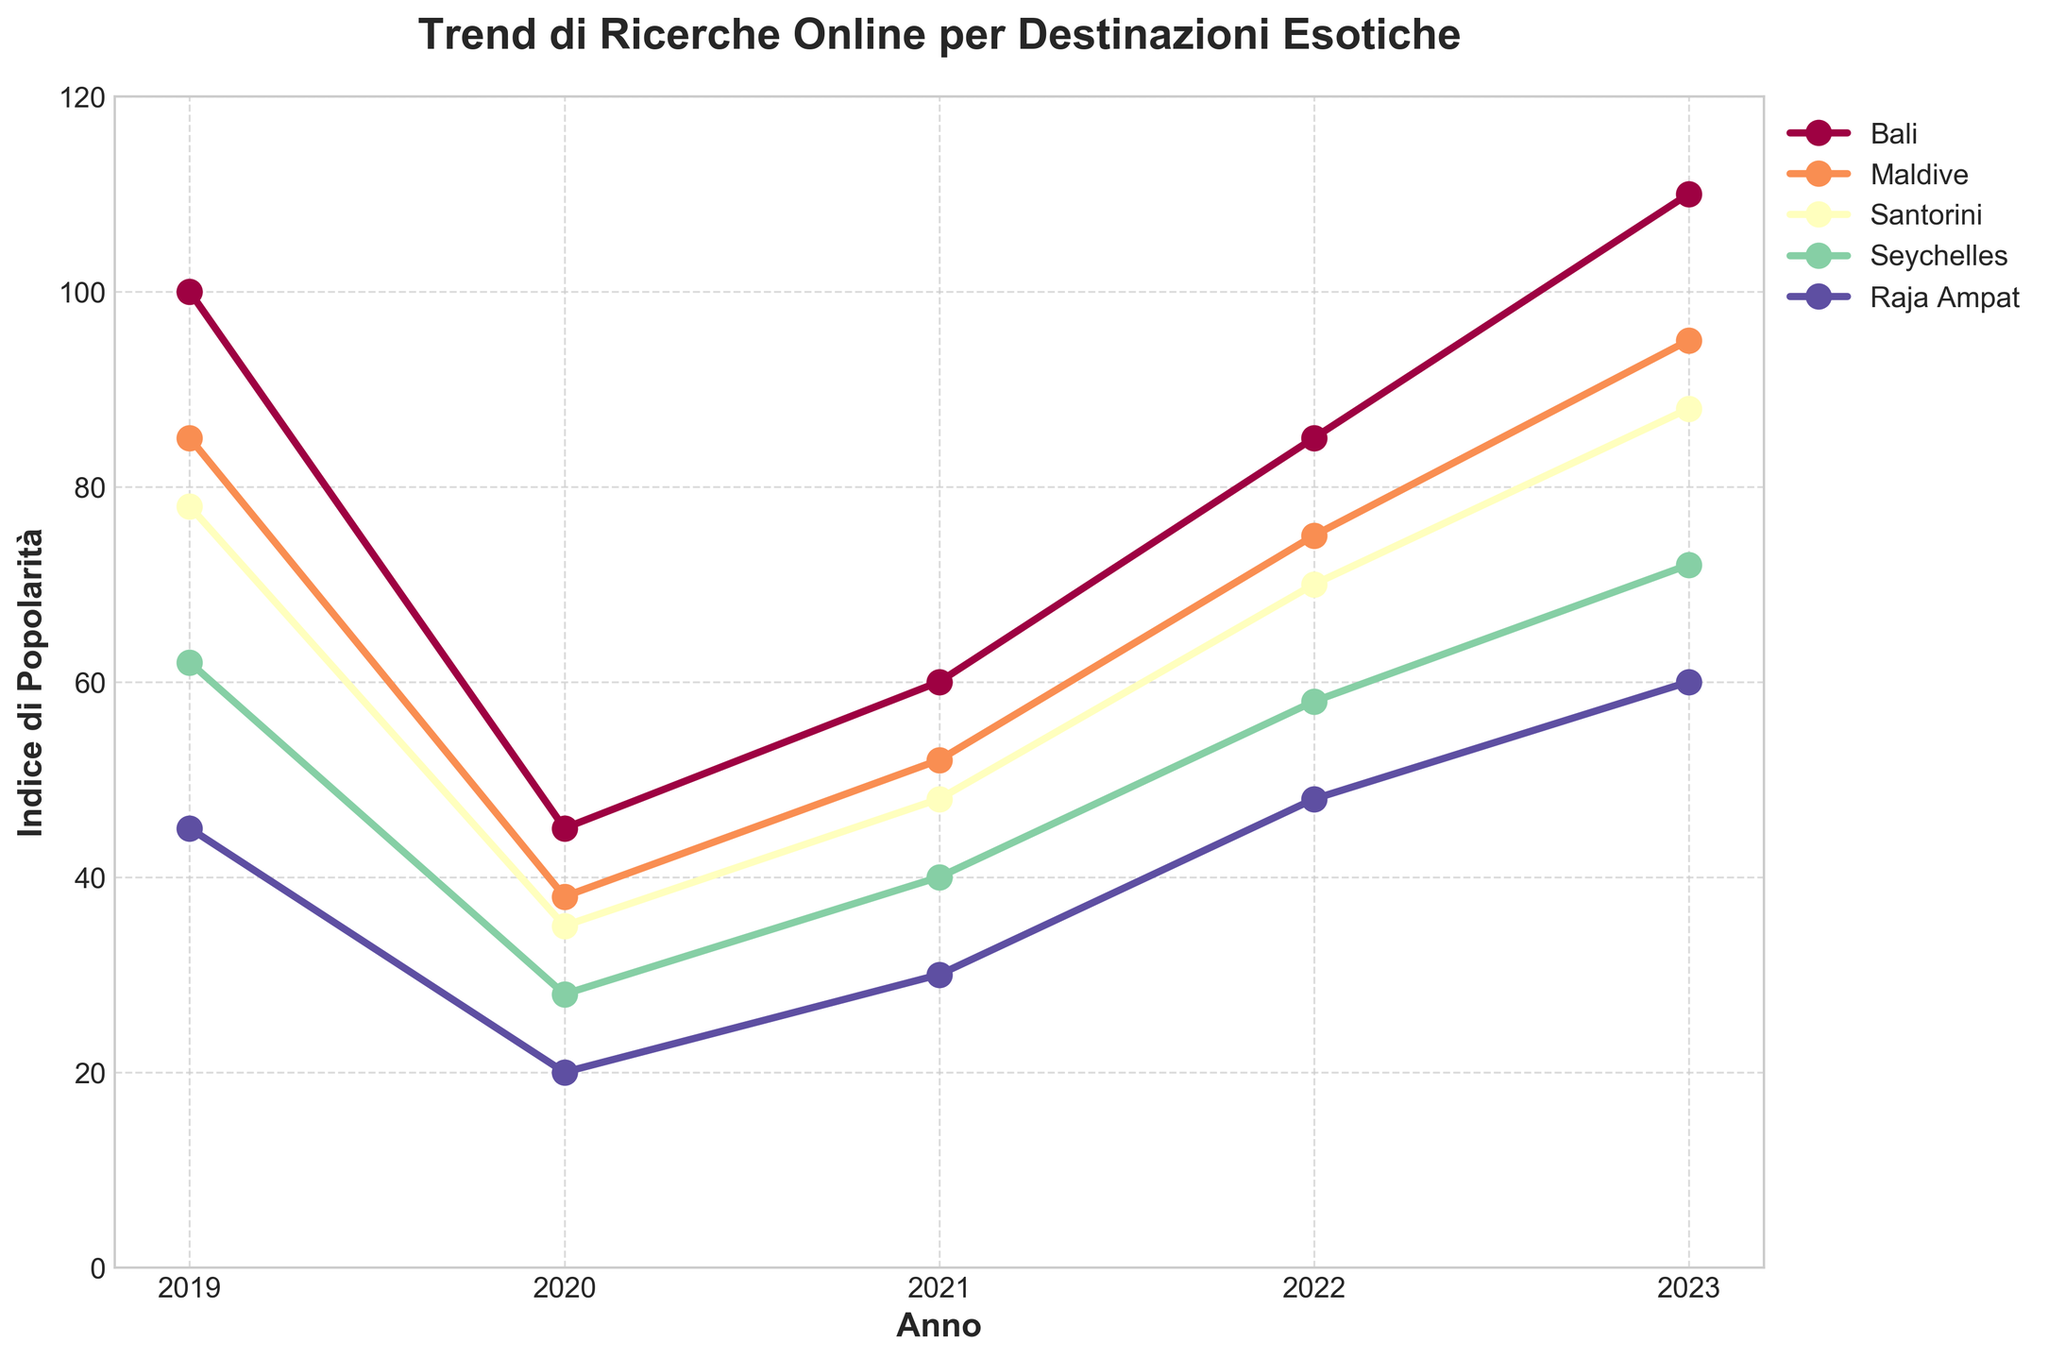Which destination had the highest search popularity in 2023? Bali had the highest search popularity shown as the highest line on the graph in 2023.
Answer: Bali By how much did the popularity of Raja Ampat increase from 2020 to 2023? In 2020, Raja Ampat's popularity was 20, and in 2023, it was 60. The increase is 60 - 20 = 40.
Answer: 40 Which destination showed the most significant increase in search popularity from 2020 to 2023? The trend lines indicate each destination's increase. Bali increased from 45 to 110, a difference of 65, the largest increase among the destinations.
Answer: Bali What was the average search popularity for Santorini over the five years? Sum the values for Santorini (78 + 35 + 48 + 70 + 88) and divide by 5. The sum is 319, and the average is 319/5 = 63.8.
Answer: 63.8 Which years did the Maldives show a decline in search popularity, and by how much? The Maldives declined from 2019 to 2020. In 2019 the value was 85, and in 2020 it was 38, a decline of 85 - 38 = 47.
Answer: 2019 to 2020, by 47 Compare the search popularity trend of Seychelles in 2022 to 2023 with that from 2021 to 2022. Which period saw a more significant increase? The popularity for Seychelles increased from 40 to 58 (18 increase) between 2021 and 2022 and from 58 to 72 (14 increase) between 2022 and 2023. The increase was more significant from 2021 to 2022.
Answer: 2021 to 2022 In 2021, which destination had the lowest search popularity? In 2021, Raja Ampat had the lowest value (30), represented by the lowest point on the graph for that year.
Answer: Raja Ampat Considering the entire period from 2019 to 2023, which destination displayed the most consistent popularity (least variation)? By observing the graphs, Seychelles showed a moderate and steady trend without drastic changes, indicating more consistent popularity.
Answer: Seychelles 